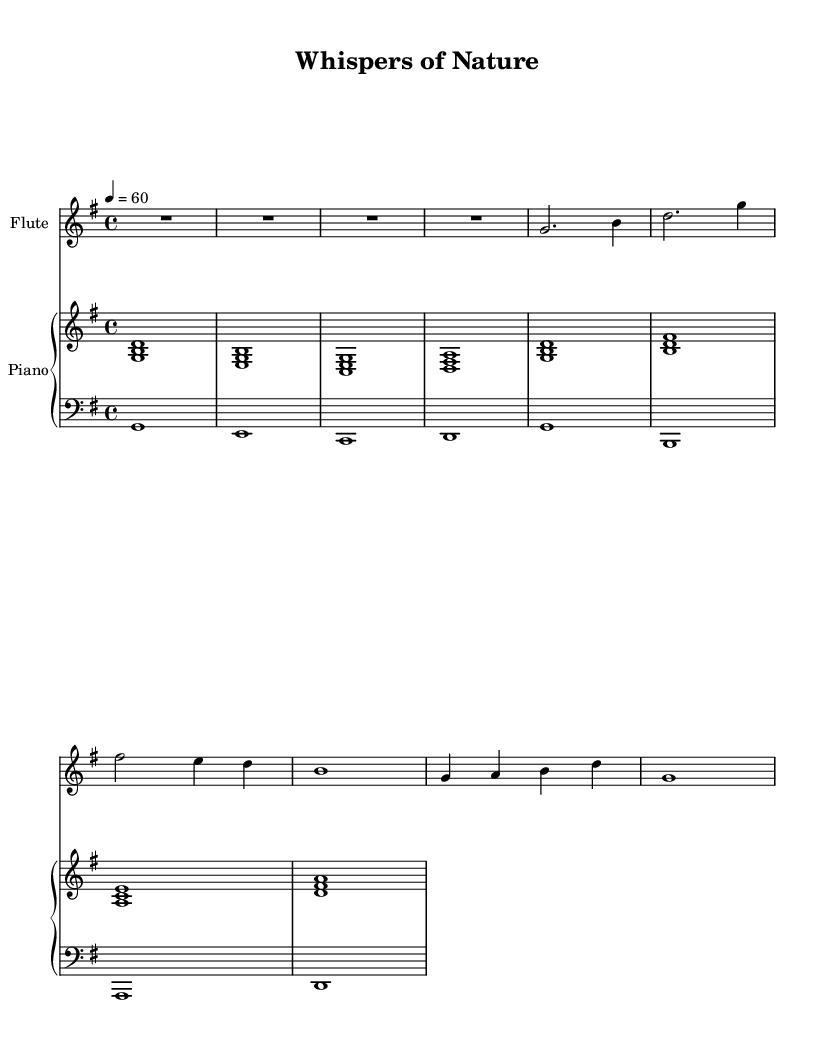what is the key signature of this music? The key signature is indicated by the sharp symbols at the beginning of the staff. In this case, it is G major, which has one sharp (F#).
Answer: G major what is the time signature of this music? The time signature is displayed as a fraction at the beginning of the staff. Here it shows 4 over 4, meaning there are four beats in a measure and the quarter note gets one beat.
Answer: 4/4 what is the tempo marking of this music? The tempo is indicated at the beginning of the music with a numerical value and a note designation. It is set at 60 beats per minute, which is a slow tempo.
Answer: 60 how many measures are in the flute part? Counting each vertical line (bar line) in the flute part gives us the number of measures. Here, we see a total of 7 measures.
Answer: 7 what is the highest pitch used in the piano part? By examining the piano staff, we identify the highest note played, which is B in the upper clef. This can be determined by looking at the range of notes in the upper staff.
Answer: B which two instruments are involved in this composition? The instruments are traditionally indicated at the start of each staff. In this composition, there is a flute staff and a piano staff, which comprises both upper and lower staves.
Answer: Flute and Piano what is the primary musical style of this composition? While the sheet music does not explicitly state the style, the combination of minimalist composition elements and subtle nature-inspired sound suggests it is meditative fusion, focusing on tranquility and natural sounds.
Answer: Meditative fusion 